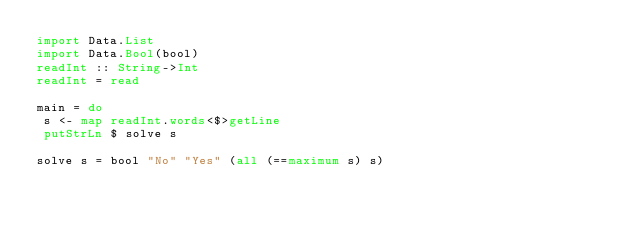Convert code to text. <code><loc_0><loc_0><loc_500><loc_500><_Haskell_>import Data.List
import Data.Bool(bool)
readInt :: String->Int
readInt = read

main = do
 s <- map readInt.words<$>getLine
 putStrLn $ solve s

solve s = bool "No" "Yes" (all (==maximum s) s)</code> 